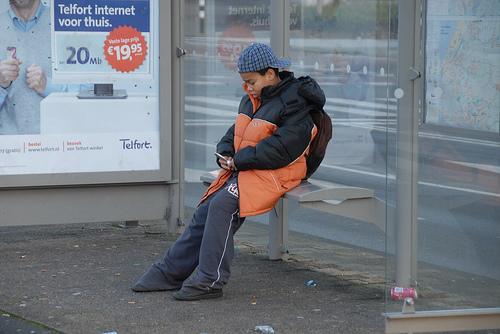Is this boy looking at a cell phone?
Concise answer only. Yes. What price is shown on the advertisement?
Keep it brief. 19.95. Is the boy wearing a winter jacket?
Keep it brief. Yes. Is this child in the train?
Keep it brief. No. 